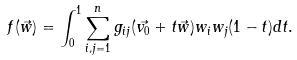<formula> <loc_0><loc_0><loc_500><loc_500>f ( \vec { w } ) = \int _ { 0 } ^ { 1 } \sum _ { i , j = 1 } ^ { n } g _ { i j } ( \vec { v _ { 0 } } + t \vec { w } ) w _ { i } w _ { j } ( 1 - t ) d t .</formula> 